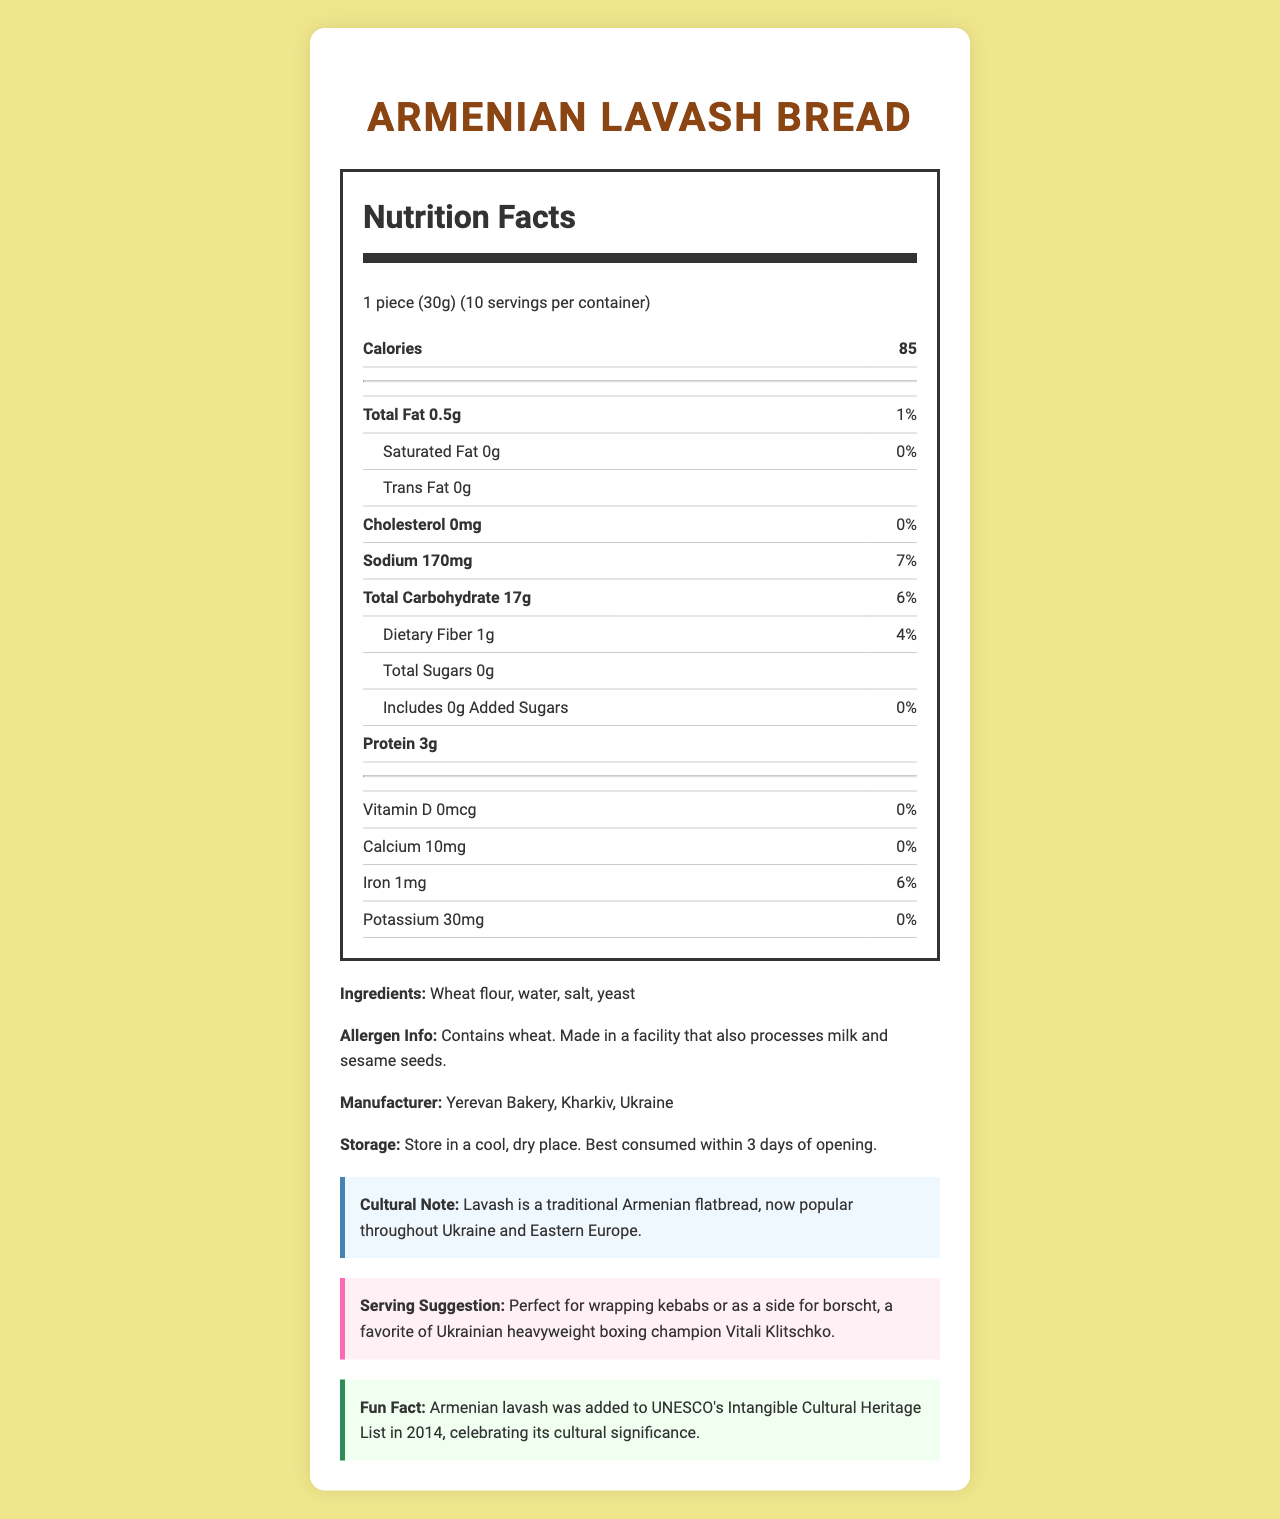what is the serving size for Armenian Lavash Bread? The serving size is clearly stated as "1 piece (30g)".
Answer: 1 piece (30g) how many servings are there in one container? The document states "servings per container: 10".
Answer: 10 what is the calorie content per serving? The calorie content per serving is listed as 85 calories.
Answer: 85 calories what is the main ingredient of the Armenian Lavash Bread? The first ingredient listed is wheat flour, indicating it is the main ingredient.
Answer: Wheat flour how much protein is in each serving? The label shows that there are 3 grams of protein per serving.
Answer: 3g what is the daily value percentage of sodium per serving? The document lists the daily value percentage of sodium as 7%.
Answer: 7% which vitamins and minerals are listed in the nutrition label? The document lists Vitamin D, Calcium, Iron, and Potassium in the nutrition facts.
Answer: Vitamin D, Calcium, Iron, Potassium where is the Armenian Lavash Bread manufactured? A. Yerevan, Armenia B. Kharkiv, Ukraine C. Kyiv, Ukraine D. Yerevan, Ukraine The manufacturer info states it is made in "Kharkiv, Ukraine".
Answer: B which of these nutrients do NOT contain any amount in the Armenian Lavash Bread? I. Cholesterol II. Trans Fat III. Total Sugars IV. Saturated Fat The nutrition facts label shows that all of these nutrients have an amount of "0g" or "0mg".
Answer: I, II, III, and IV is the Armenian Lavash Bread suitable for someone with a sesame allergy? The allergen info states that it is made in a facility that processes sesame seeds, which may pose a risk for someone with a sesame allergy.
Answer: No does the Armenian Lavash Bread contain any added sugars? The document states that there are 0g of added sugars.
Answer: No summarize the general characteristics and nutritional information of Armenian Lavash Bread. The summary encapsulates the main nutritional details, ingredients, manufacturing information, and cultural context as provided in the document.
Answer: Armenian Lavash Bread is a traditional flatbread with a serving size of 1 piece (30g) containing 85 calories. It has low fat, no saturated fat, or cholesterol but contains 170mg of sodium (7% DV). It provides 17g of carbohydrates (6% DV) including 1g of dietary fiber (4% DV) and 3g of protein. The bread is made from wheat flour, water, salt, and yeast, and is manufactured in Kharkiv, Ukraine. Additionally, it is connected to cultural traditions and is recommended for wrapping kebabs or accompanying borscht. who is the favorite Ukrainian heavyweight boxing champion mentioned in the document? The serving suggestion mentions Vitali Klitschko as a favorite Ukrainian heavyweight boxing champion.
Answer: Vitali Klitschko how does Armenian Lavash Bread compare to most sandwich breads regarding calories and fat content? The document states that Armenian Lavash Bread has fewer calories and less fat than most sandwich breads.
Answer: Fewer calories and less fat what is the expiration period after opening the package of Armenian Lavash Bread? The storage instructions note that it is best consumed within 3 days of opening.
Answer: 3 days what year was Armenian lavash added to UNESCO's Intangible Cultural Heritage List? The fun fact states that this occurred in 2014.
Answer: 2014 how many milligrams of calcium are there in each serving of Armenian Lavash Bread? The document lists the calcium content as 10mg.
Answer: 10mg is the Armenian Lavash Bread considered gluten-free? The document does not provide information regarding gluten content.
Answer: Cannot be determined 